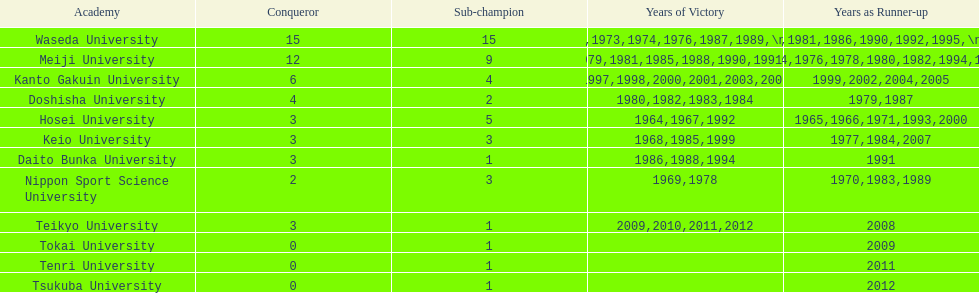Hosei won in 1964. who won the next year? Waseda University. Help me parse the entirety of this table. {'header': ['Academy', 'Conqueror', 'Sub-champion', 'Years of Victory', 'Years as Runner-up'], 'rows': [['Waseda University', '15', '15', '1965,1966,1968,1970,1971,1973,1974,1976,1987,1989,\\n2002,2004,2005,2007,2008', '1964,1967,1969,1972,1975,1981,1986,1990,1992,1995,\\n1996,2001,2003,2006,2010'], ['Meiji University', '12', '9', '1972,1975,1977,1979,1981,1985,1988,1990,1991,1993,\\n1995,1996', '1973,1974,1976,1978,1980,1982,1994,1997,1998'], ['Kanto Gakuin University', '6', '4', '1997,1998,2000,2001,2003,2006', '1999,2002,2004,2005'], ['Doshisha University', '4', '2', '1980,1982,1983,1984', '1979,1987'], ['Hosei University', '3', '5', '1964,1967,1992', '1965,1966,1971,1993,2000'], ['Keio University', '3', '3', '1968,1985,1999', '1977,1984,2007'], ['Daito Bunka University', '3', '1', '1986,1988,1994', '1991'], ['Nippon Sport Science University', '2', '3', '1969,1978', '1970,1983,1989'], ['Teikyo University', '3', '1', '2009,2010,2011,2012', '2008'], ['Tokai University', '0', '1', '', '2009'], ['Tenri University', '0', '1', '', '2011'], ['Tsukuba University', '0', '1', '', '2012']]} 